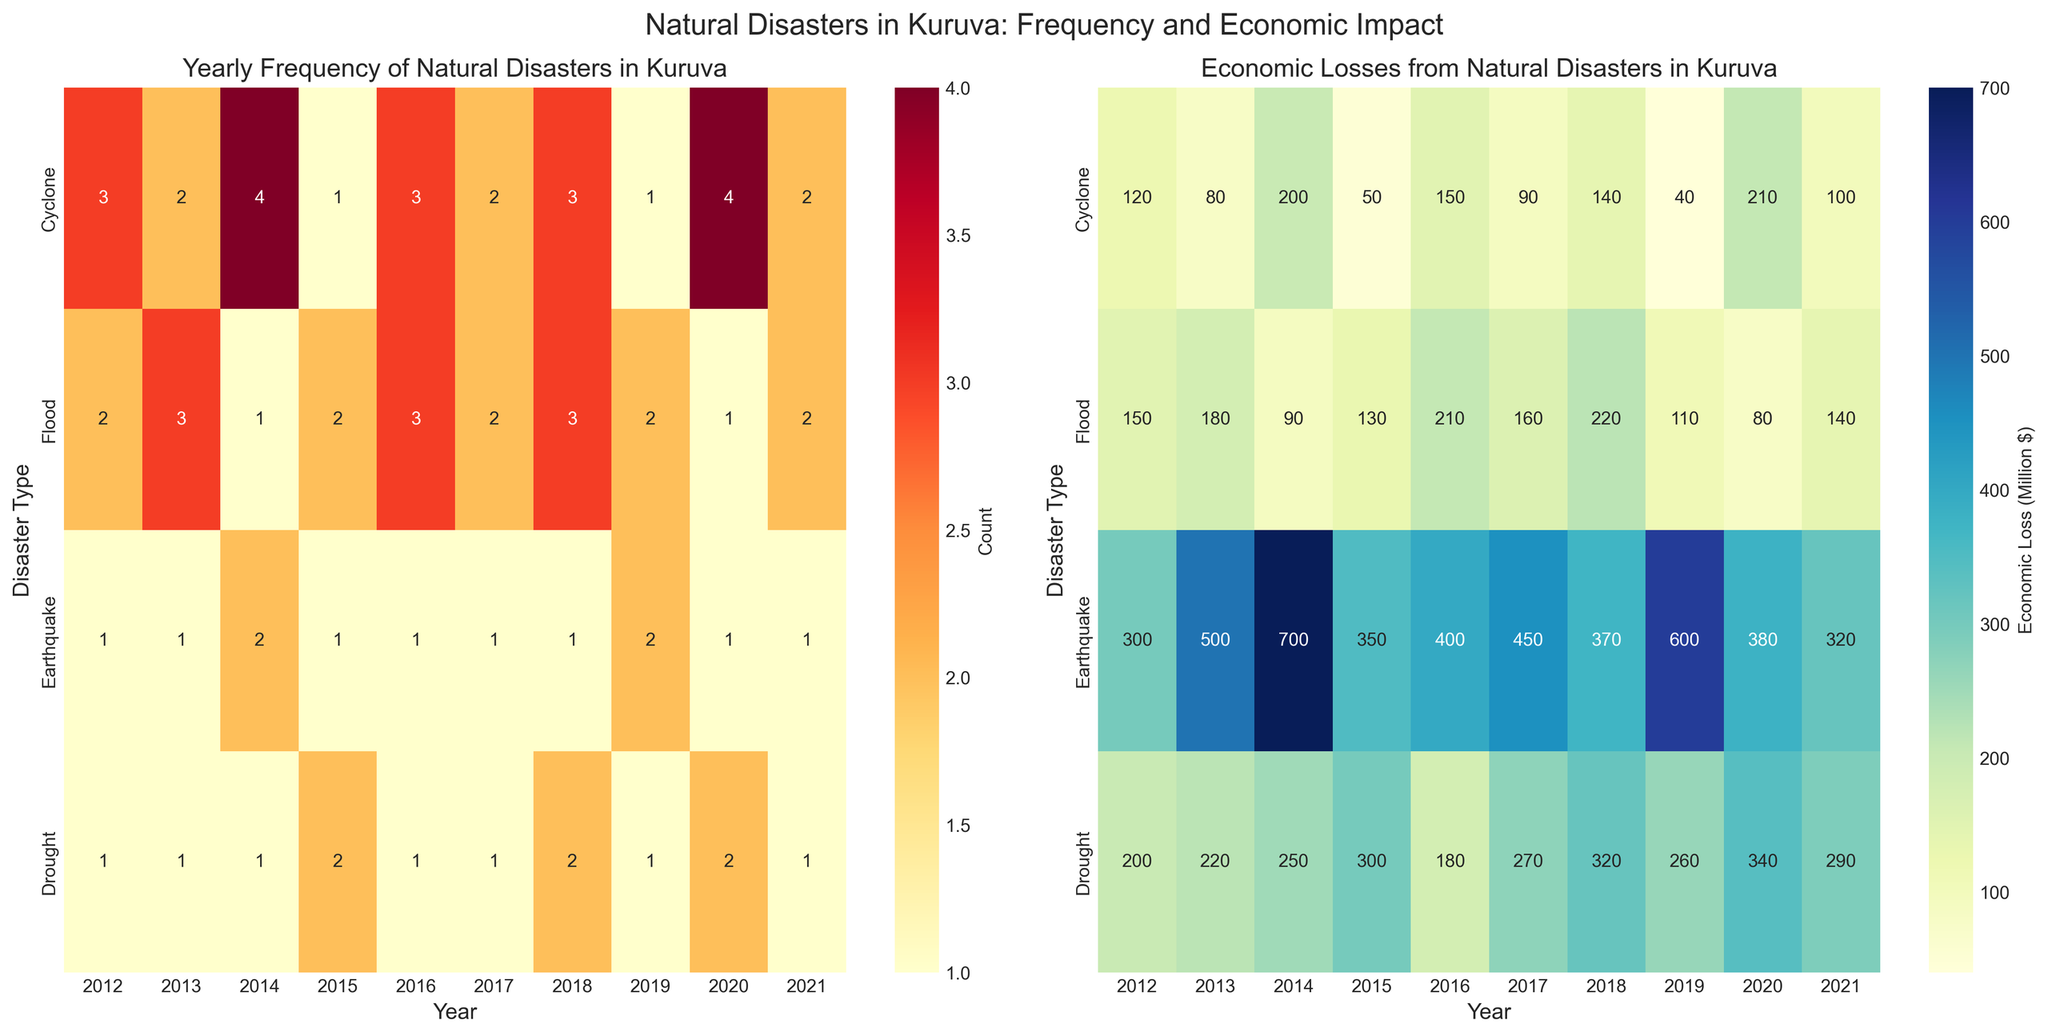What's the title of the left heatmap? Look at the title above the left heatmap; it should describe the yearly frequency of natural disasters.
Answer: Yearly Frequency of Natural Disasters in Kuruva Which year had the highest frequency of earthquakes? Examine the row corresponding to 'Earthquake' in the left heatmap for the cell with the highest count.
Answer: 2014 and 2019 What is the color associated with the highest economic loss due to floods? Look at the color gradient bar labeled 'Economic Loss (Million $)' on the right heatmap and find the color at the most intense end.
Answer: Dark blue In which year did droughts cause the highest economic loss? Find the row for 'Drought' in the right heatmap and look for the cell with the highest value.
Answer: 2020 How many more cyclones occurred in 2014 compared to 2015? Look at the 'Cyclone' row in the left heatmap and find the difference between the values for 2014 and 2015.
Answer: 3 What was the total economic loss caused by earthquakes in Kuruva in the year 2015? Find the cell in the 'Earthquake' row and the column for 2015 in the right heatmap.
Answer: 350 Million $ Which type of natural disaster had the lowest economic impact in 2018? Look at the right heatmap for the year 2018 and identify the row with the lowest value.
Answer: Earthquake What's the average number of floods per year from 2012 to 2021? Add all flood counts from 2012 to 2021, then divide by the number of years (10). (2+3+1+2+3+2+3+2+1+2)/10 = 2.1
Answer: 2.1 Between 2013 and 2020, which year had the lowest total economic loss from all natural disasters? Sum economic losses for all disasters for each year between 2013 and 2020 and find the year with the smallest total.
Answer: 2015 Is there any year with zero natural disasters recorded? Look at the left heatmap for any column where all cells have a count of '0'.
Answer: No 